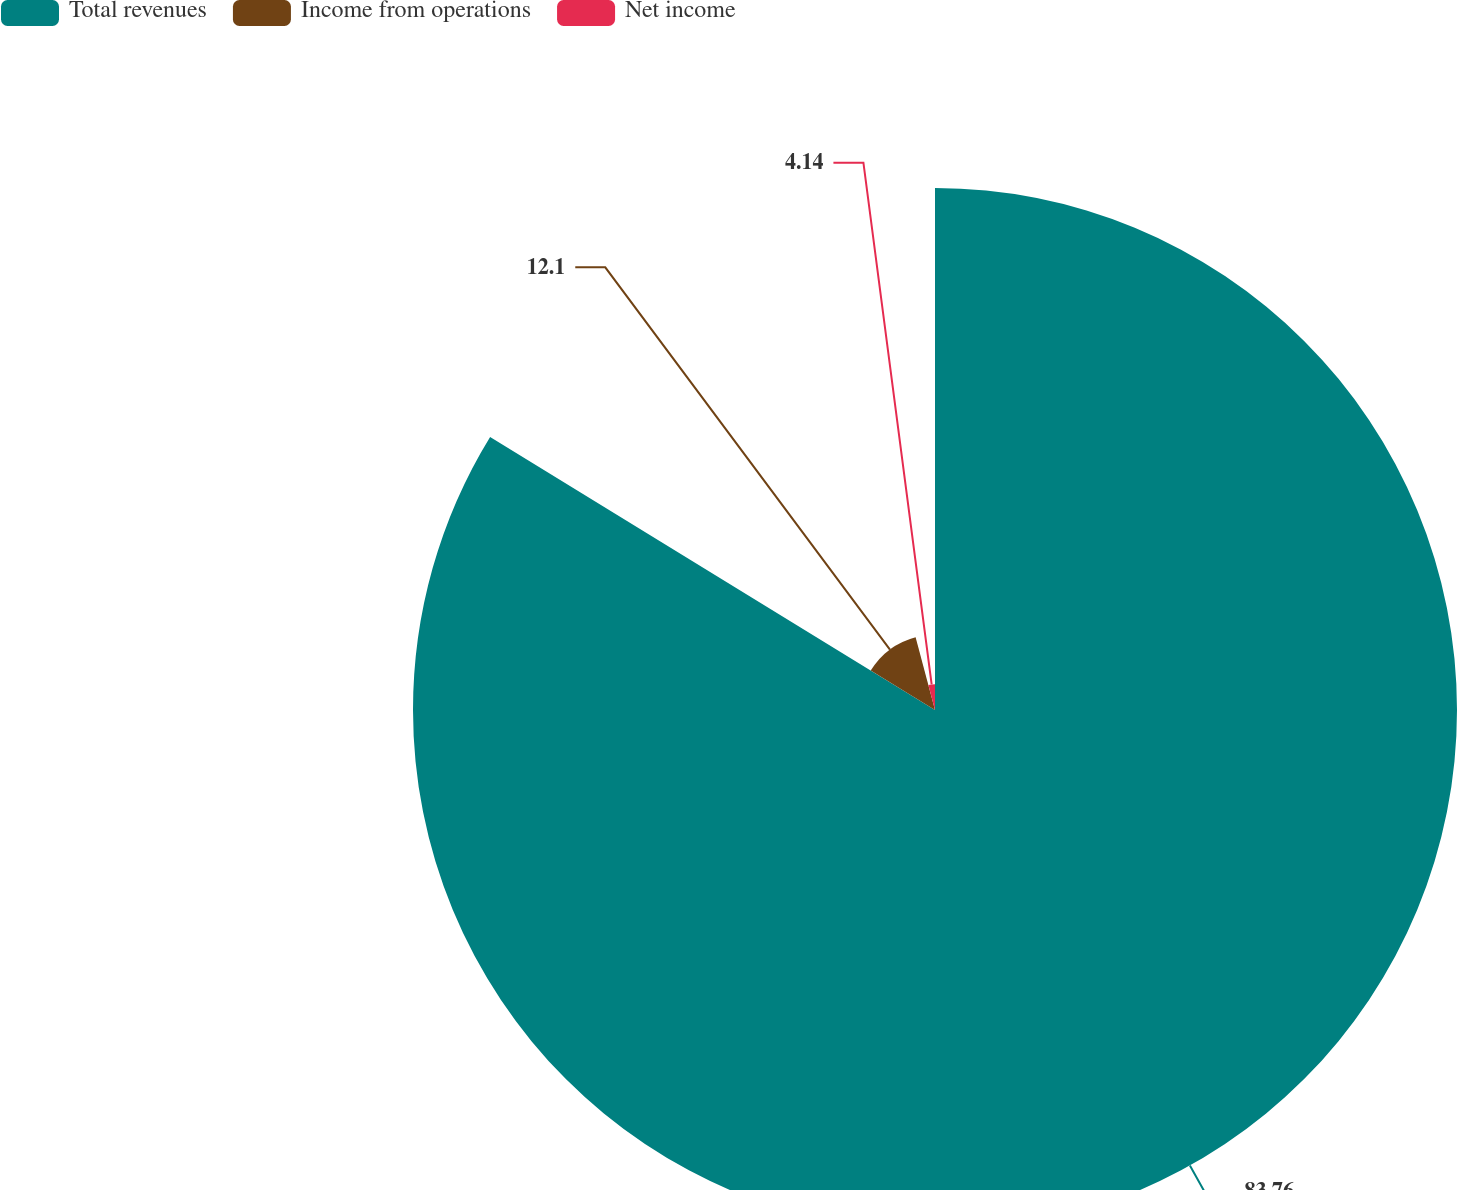Convert chart to OTSL. <chart><loc_0><loc_0><loc_500><loc_500><pie_chart><fcel>Total revenues<fcel>Income from operations<fcel>Net income<nl><fcel>83.77%<fcel>12.1%<fcel>4.14%<nl></chart> 